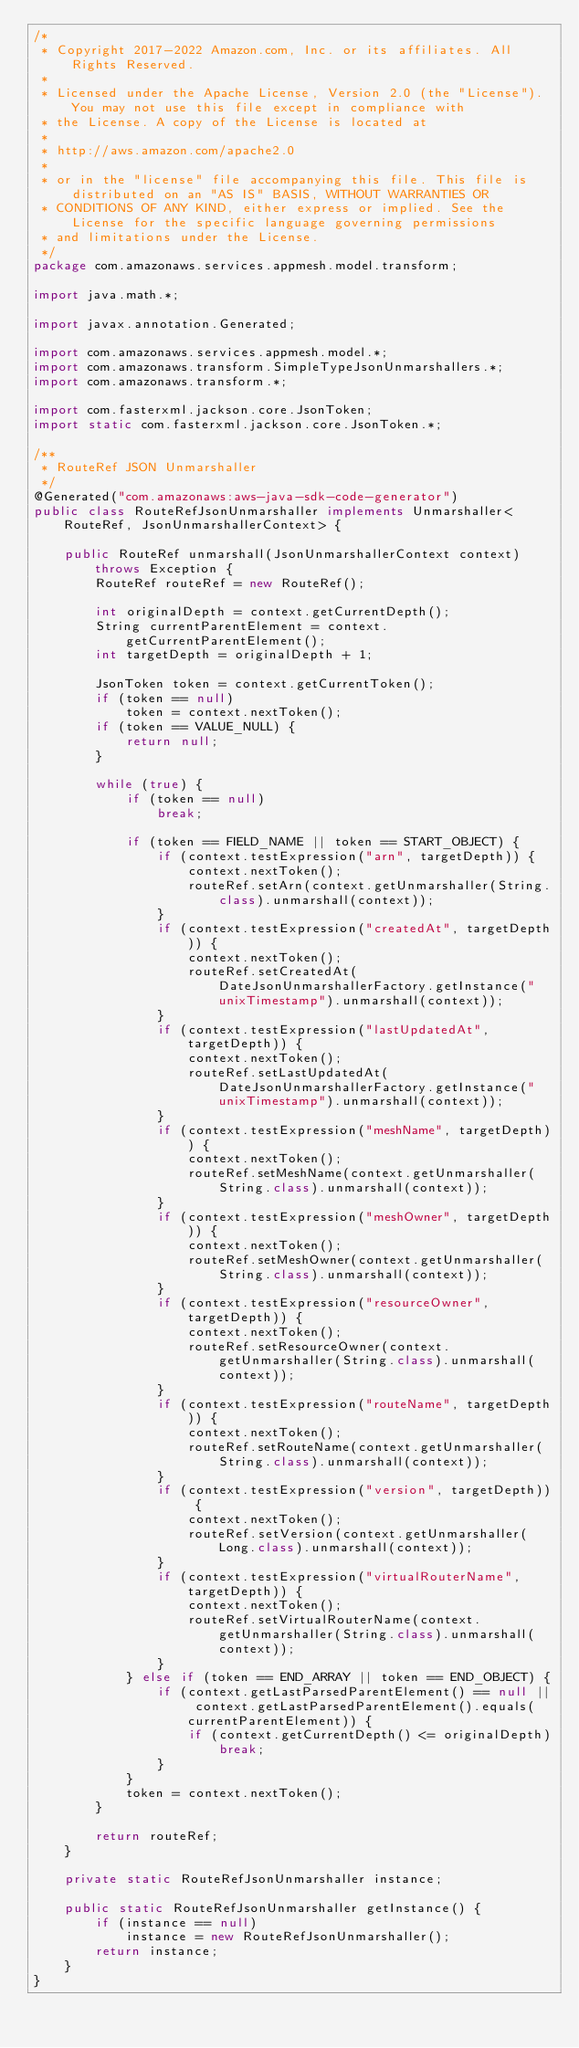<code> <loc_0><loc_0><loc_500><loc_500><_Java_>/*
 * Copyright 2017-2022 Amazon.com, Inc. or its affiliates. All Rights Reserved.
 * 
 * Licensed under the Apache License, Version 2.0 (the "License"). You may not use this file except in compliance with
 * the License. A copy of the License is located at
 * 
 * http://aws.amazon.com/apache2.0
 * 
 * or in the "license" file accompanying this file. This file is distributed on an "AS IS" BASIS, WITHOUT WARRANTIES OR
 * CONDITIONS OF ANY KIND, either express or implied. See the License for the specific language governing permissions
 * and limitations under the License.
 */
package com.amazonaws.services.appmesh.model.transform;

import java.math.*;

import javax.annotation.Generated;

import com.amazonaws.services.appmesh.model.*;
import com.amazonaws.transform.SimpleTypeJsonUnmarshallers.*;
import com.amazonaws.transform.*;

import com.fasterxml.jackson.core.JsonToken;
import static com.fasterxml.jackson.core.JsonToken.*;

/**
 * RouteRef JSON Unmarshaller
 */
@Generated("com.amazonaws:aws-java-sdk-code-generator")
public class RouteRefJsonUnmarshaller implements Unmarshaller<RouteRef, JsonUnmarshallerContext> {

    public RouteRef unmarshall(JsonUnmarshallerContext context) throws Exception {
        RouteRef routeRef = new RouteRef();

        int originalDepth = context.getCurrentDepth();
        String currentParentElement = context.getCurrentParentElement();
        int targetDepth = originalDepth + 1;

        JsonToken token = context.getCurrentToken();
        if (token == null)
            token = context.nextToken();
        if (token == VALUE_NULL) {
            return null;
        }

        while (true) {
            if (token == null)
                break;

            if (token == FIELD_NAME || token == START_OBJECT) {
                if (context.testExpression("arn", targetDepth)) {
                    context.nextToken();
                    routeRef.setArn(context.getUnmarshaller(String.class).unmarshall(context));
                }
                if (context.testExpression("createdAt", targetDepth)) {
                    context.nextToken();
                    routeRef.setCreatedAt(DateJsonUnmarshallerFactory.getInstance("unixTimestamp").unmarshall(context));
                }
                if (context.testExpression("lastUpdatedAt", targetDepth)) {
                    context.nextToken();
                    routeRef.setLastUpdatedAt(DateJsonUnmarshallerFactory.getInstance("unixTimestamp").unmarshall(context));
                }
                if (context.testExpression("meshName", targetDepth)) {
                    context.nextToken();
                    routeRef.setMeshName(context.getUnmarshaller(String.class).unmarshall(context));
                }
                if (context.testExpression("meshOwner", targetDepth)) {
                    context.nextToken();
                    routeRef.setMeshOwner(context.getUnmarshaller(String.class).unmarshall(context));
                }
                if (context.testExpression("resourceOwner", targetDepth)) {
                    context.nextToken();
                    routeRef.setResourceOwner(context.getUnmarshaller(String.class).unmarshall(context));
                }
                if (context.testExpression("routeName", targetDepth)) {
                    context.nextToken();
                    routeRef.setRouteName(context.getUnmarshaller(String.class).unmarshall(context));
                }
                if (context.testExpression("version", targetDepth)) {
                    context.nextToken();
                    routeRef.setVersion(context.getUnmarshaller(Long.class).unmarshall(context));
                }
                if (context.testExpression("virtualRouterName", targetDepth)) {
                    context.nextToken();
                    routeRef.setVirtualRouterName(context.getUnmarshaller(String.class).unmarshall(context));
                }
            } else if (token == END_ARRAY || token == END_OBJECT) {
                if (context.getLastParsedParentElement() == null || context.getLastParsedParentElement().equals(currentParentElement)) {
                    if (context.getCurrentDepth() <= originalDepth)
                        break;
                }
            }
            token = context.nextToken();
        }

        return routeRef;
    }

    private static RouteRefJsonUnmarshaller instance;

    public static RouteRefJsonUnmarshaller getInstance() {
        if (instance == null)
            instance = new RouteRefJsonUnmarshaller();
        return instance;
    }
}
</code> 